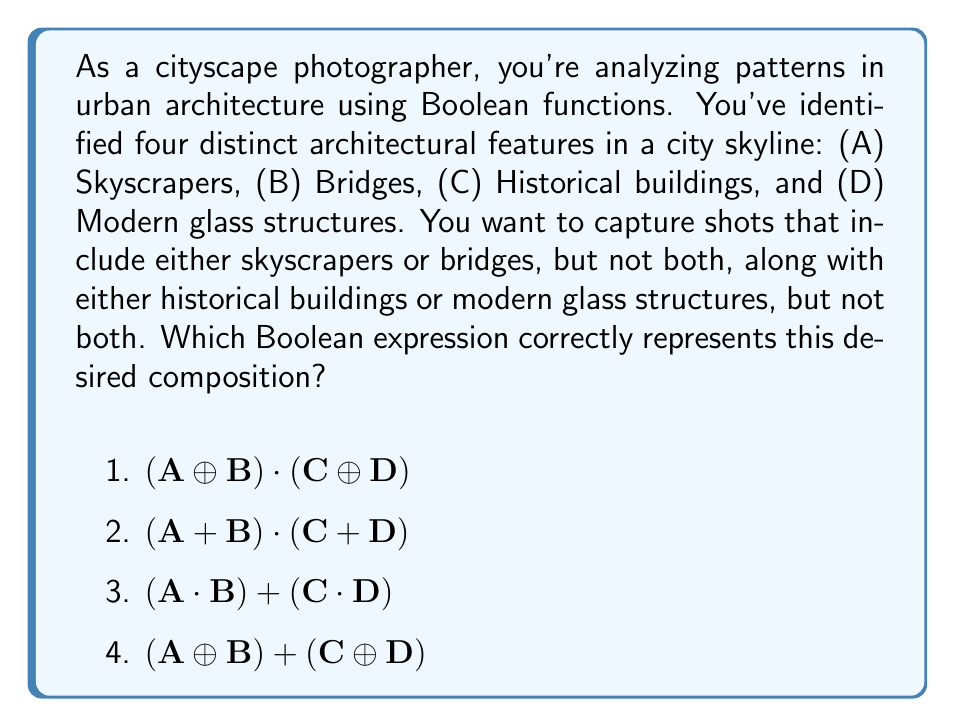Teach me how to tackle this problem. Let's break this down step-by-step:

1) We need to represent "either skyscrapers or bridges, but not both". This is the definition of the XOR operation, symbolized by $\oplus$. So for the first part, we need $A \oplus B$.

2) Similarly, for "either historical buildings or modern glass structures, but not both", we need $C \oplus D$.

3) We want both of these conditions to be true simultaneously. In Boolean algebra, the AND operation is represented by multiplication (·). 

4) Therefore, we need to combine the two XOR operations with an AND operation:

   $(A \oplus B) \cdot (C \oplus D)$

5) Let's verify this:
   - If A=1, B=0, C=1, D=0, the expression is true (1·1 = 1)
   - If A=1, B=0, C=0, D=1, the expression is true (1·1 = 1)
   - If A=1, B=1, C=1, D=0, the expression is false (0·1 = 0)
   - If A=0, B=0, C=1, D=0, the expression is false (0·1 = 0)

6) This matches our desired outcome: we get a true result only when we have either A or B (but not both) AND either C or D (but not both).

Therefore, the correct answer is option 1: $(A \oplus B) \cdot (C \oplus D)$.
Answer: $(A \oplus B) \cdot (C \oplus D)$ 